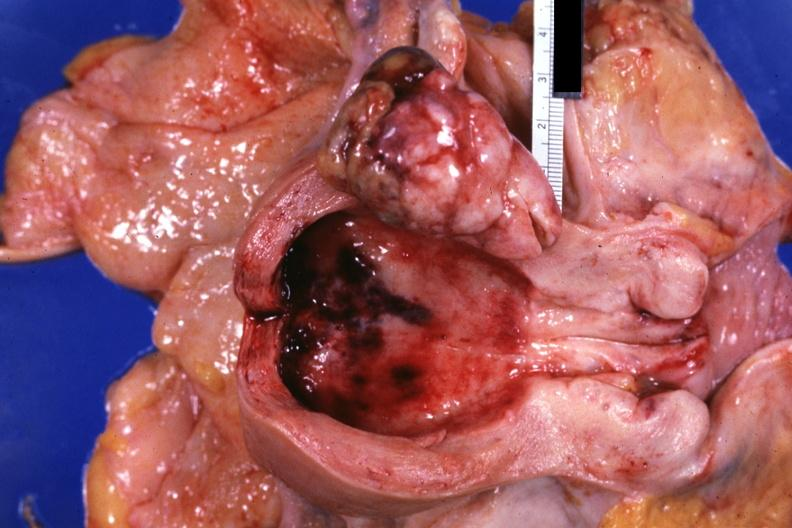does intraductal papillomatosis with apocrine metaplasia show opened uterus polypoid tumor demonstrated?
Answer the question using a single word or phrase. No 